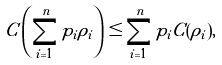<formula> <loc_0><loc_0><loc_500><loc_500>C \left ( \sum _ { i = 1 } ^ { n } p _ { i } \rho _ { i } \right ) \leq \sum _ { i = 1 } ^ { n } p _ { i } C ( \rho _ { i } ) ,</formula> 